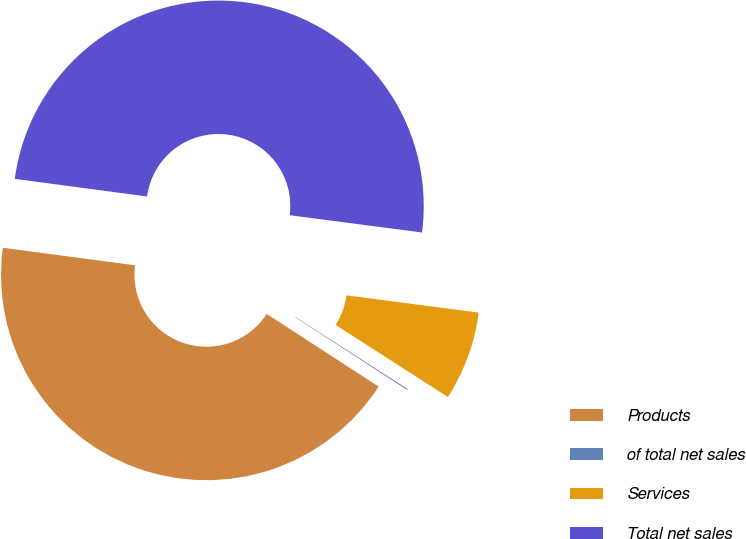Convert chart to OTSL. <chart><loc_0><loc_0><loc_500><loc_500><pie_chart><fcel>Products<fcel>of total net sales<fcel>Services<fcel>Total net sales<nl><fcel>42.94%<fcel>0.08%<fcel>7.02%<fcel>49.96%<nl></chart> 